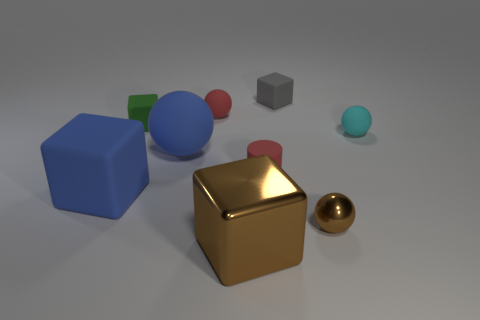Subtract 1 balls. How many balls are left? 3 Add 1 small blocks. How many objects exist? 10 Subtract all cylinders. How many objects are left? 8 Subtract all small matte spheres. Subtract all tiny green objects. How many objects are left? 6 Add 3 tiny brown balls. How many tiny brown balls are left? 4 Add 3 small red metal objects. How many small red metal objects exist? 3 Subtract 1 cyan spheres. How many objects are left? 8 